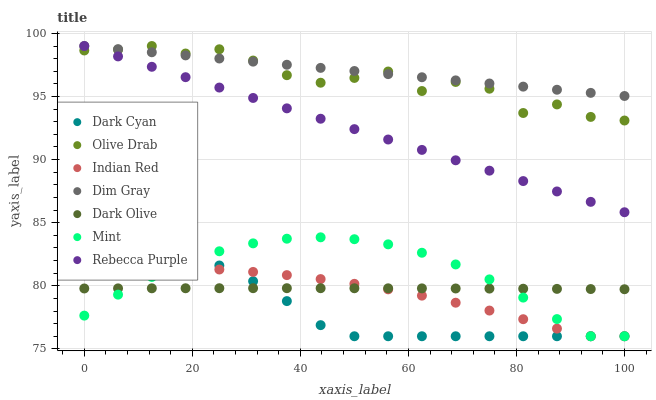Does Dark Cyan have the minimum area under the curve?
Answer yes or no. Yes. Does Dim Gray have the maximum area under the curve?
Answer yes or no. Yes. Does Dark Olive have the minimum area under the curve?
Answer yes or no. No. Does Dark Olive have the maximum area under the curve?
Answer yes or no. No. Is Rebecca Purple the smoothest?
Answer yes or no. Yes. Is Olive Drab the roughest?
Answer yes or no. Yes. Is Dark Olive the smoothest?
Answer yes or no. No. Is Dark Olive the roughest?
Answer yes or no. No. Does Indian Red have the lowest value?
Answer yes or no. Yes. Does Dark Olive have the lowest value?
Answer yes or no. No. Does Olive Drab have the highest value?
Answer yes or no. Yes. Does Dark Olive have the highest value?
Answer yes or no. No. Is Dark Olive less than Olive Drab?
Answer yes or no. Yes. Is Dim Gray greater than Mint?
Answer yes or no. Yes. Does Dim Gray intersect Rebecca Purple?
Answer yes or no. Yes. Is Dim Gray less than Rebecca Purple?
Answer yes or no. No. Is Dim Gray greater than Rebecca Purple?
Answer yes or no. No. Does Dark Olive intersect Olive Drab?
Answer yes or no. No. 